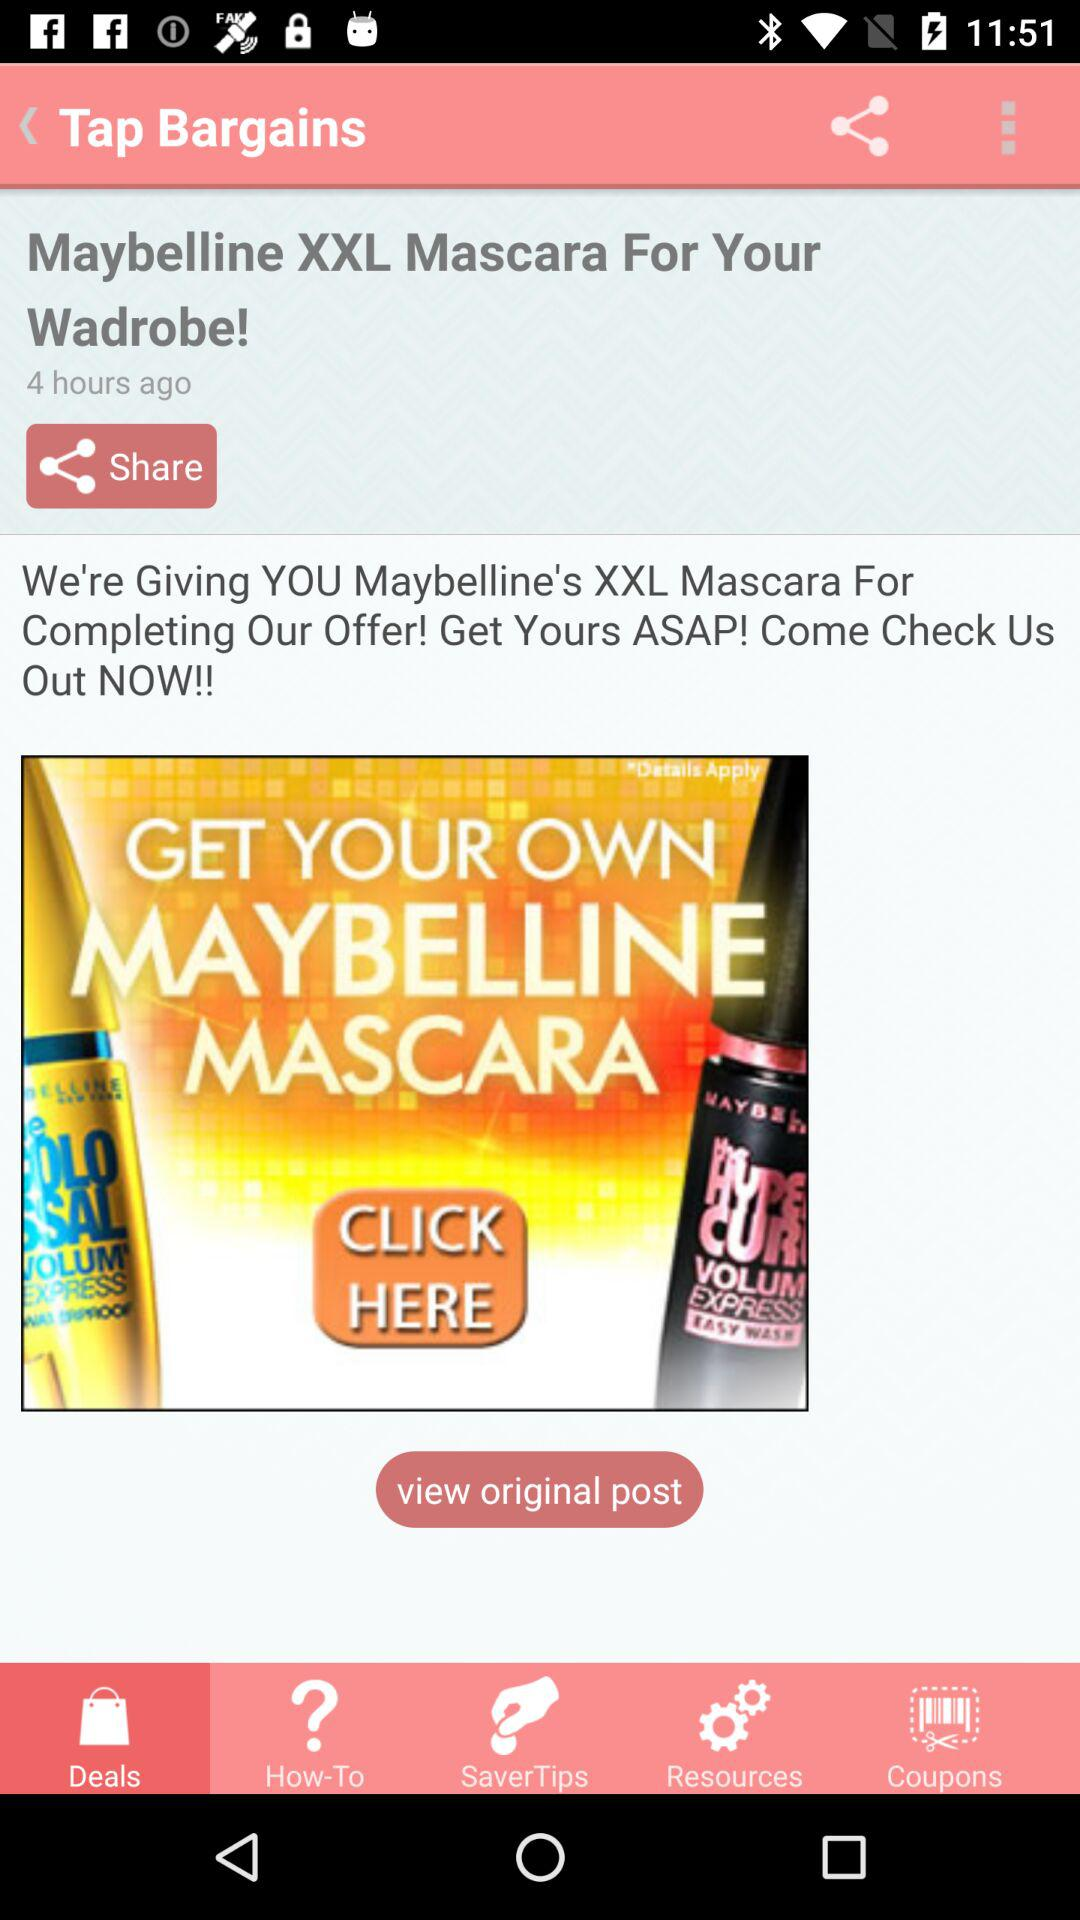How many hours ago was the post published?
Answer the question using a single word or phrase. 4 